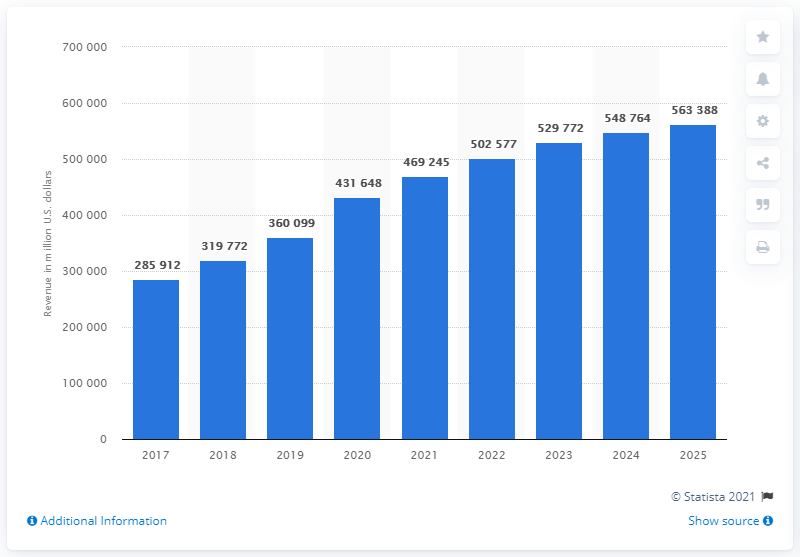What trends can we observe from the e-commerce revenue growth in the United States from 2017 to 2025 according to the graph? The graph shows a consistent upward trend in e-commerce revenue in the United States from 2017 onwards, with projected continued growth up to 2025. This indicates increased consumer reliance on online shopping, advancements in e-commerce technology, and expansion of digital marketplaces.  Is there a year where the growth rate seems to have spiked more than others? Based on the visual data, there's a notable increase in revenue from 2019 to 2020, suggesting a surge in e-commerce usage, which could be attributed to circumstances such as the Covid-19 pandemic that prompted more consumers to shop online. 